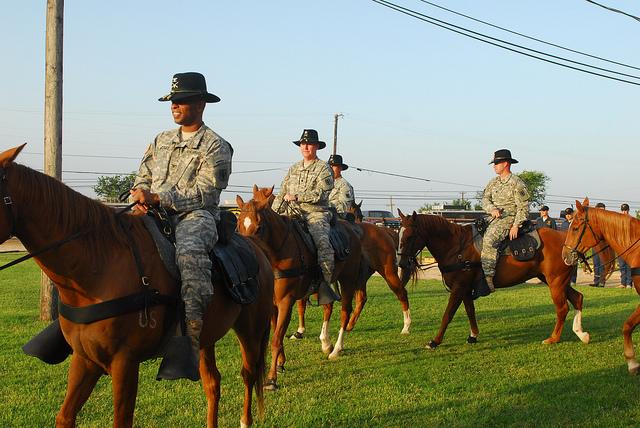Are these men in uniform?
Give a very brief answer. Yes. How many horse are there?
Answer briefly. 5. What color is the closest horse?
Give a very brief answer. Brown. 